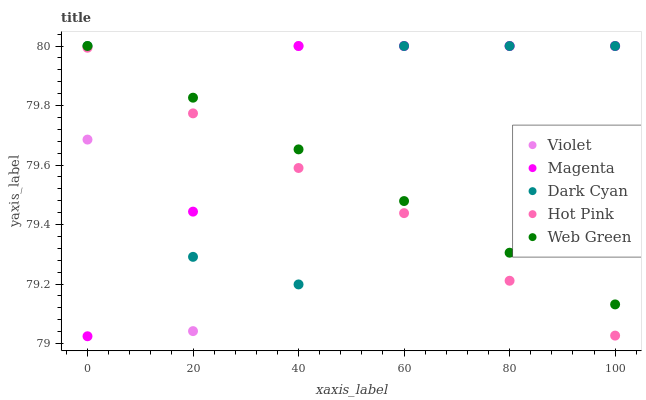Does Hot Pink have the minimum area under the curve?
Answer yes or no. Yes. Does Magenta have the maximum area under the curve?
Answer yes or no. Yes. Does Magenta have the minimum area under the curve?
Answer yes or no. No. Does Hot Pink have the maximum area under the curve?
Answer yes or no. No. Is Web Green the smoothest?
Answer yes or no. Yes. Is Violet the roughest?
Answer yes or no. Yes. Is Magenta the smoothest?
Answer yes or no. No. Is Magenta the roughest?
Answer yes or no. No. Does Magenta have the lowest value?
Answer yes or no. Yes. Does Hot Pink have the lowest value?
Answer yes or no. No. Does Violet have the highest value?
Answer yes or no. Yes. Does Hot Pink have the highest value?
Answer yes or no. No. Is Hot Pink less than Web Green?
Answer yes or no. Yes. Is Web Green greater than Hot Pink?
Answer yes or no. Yes. Does Web Green intersect Magenta?
Answer yes or no. Yes. Is Web Green less than Magenta?
Answer yes or no. No. Is Web Green greater than Magenta?
Answer yes or no. No. Does Hot Pink intersect Web Green?
Answer yes or no. No. 